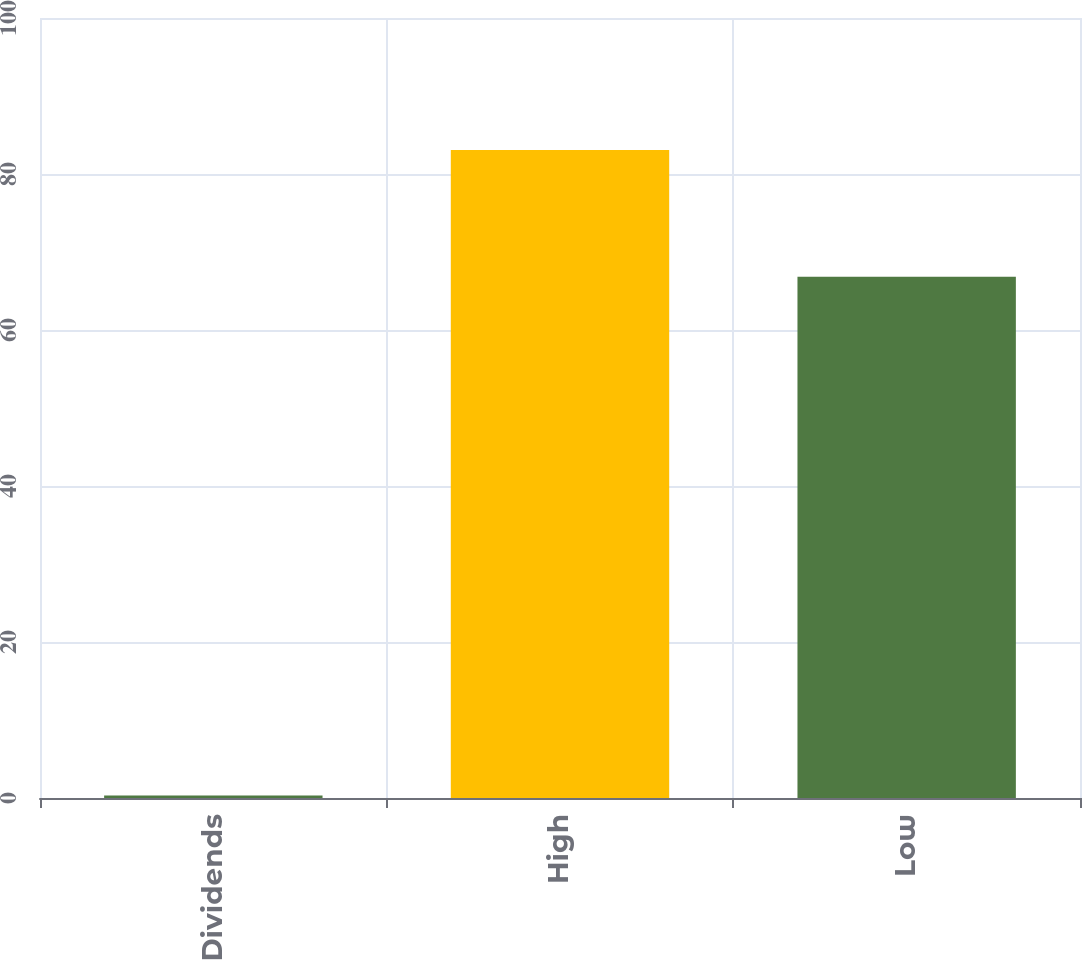<chart> <loc_0><loc_0><loc_500><loc_500><bar_chart><fcel>Dividends<fcel>High<fcel>Low<nl><fcel>0.33<fcel>83.08<fcel>66.84<nl></chart> 